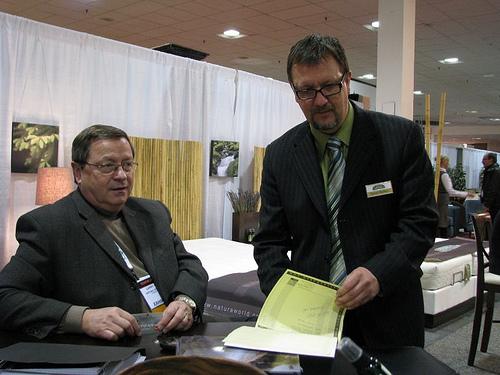What are the people in the background doing?
Short answer required. Talking. Could this be a convention?
Quick response, please. Yes. Are the men business partners?
Keep it brief. Yes. 